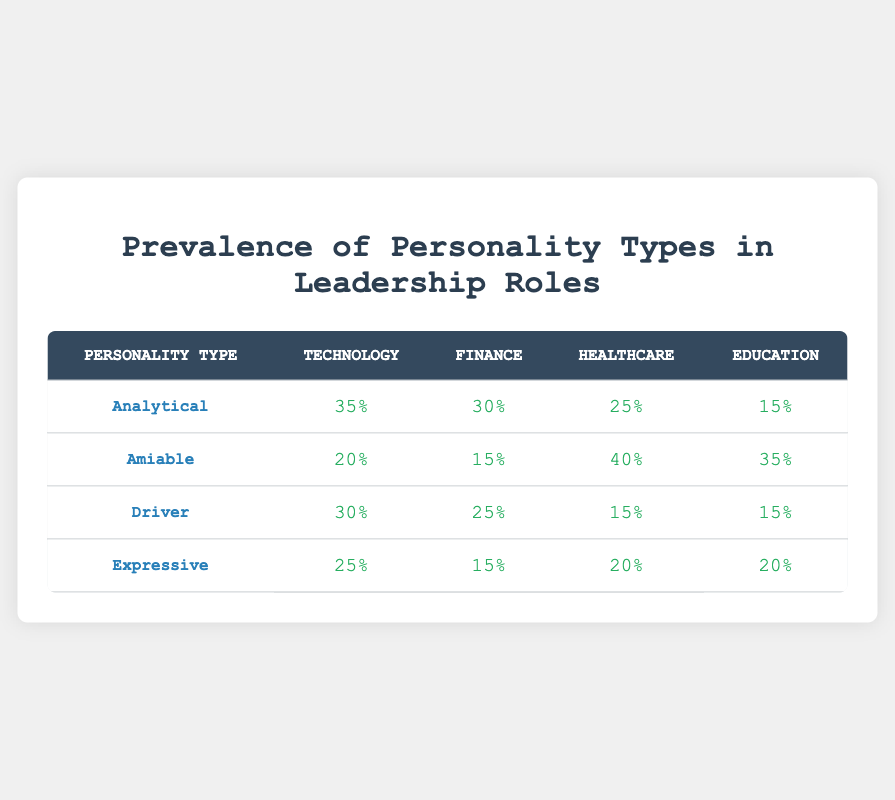What is the prevalence of Analytical personality types in the Technology sector? According to the table, the prevalence of Analytical personality types in the Technology sector is 35%.
Answer: 35% Which personality type has the highest prevalence in Healthcare? By looking at the Healthcare column, the Amiable personality type has the highest prevalence at 40%.
Answer: Amiable What is the average prevalence of the Expressive personality type across all industries? Adding the prevalence values of Expressive personality types: (25 + 15 + 20 + 20) = 80. Dividing this by the number of industries, which is 4, gives 80/4 = 20.
Answer: 20 Is it true that the Driver personality type has the lowest prevalence in Education? The table shows that the prevalence for the Driver personality type in Education is 15%, which is the same as its prevalence in Healthcare. However, the Amiable type has a higher prevalence of 35%, confirming that Driver is the lowest. Therefore, this statement is true.
Answer: Yes Which personality type is the most prevalent in the Finance sector? In the Finance sector, the highest values are for Analytical at 30% and Driver at 25%. Therefore, Analytical has the highest prevalence.
Answer: Analytical What is the difference in prevalence for the Amiable personality type between Healthcare and Technology? The Amiable prevalence in Healthcare is 40%, and in Technology, it is 20%. The difference is calculated as 40 - 20 = 20.
Answer: 20 Which industry shows a balanced prevalence of all personality types? By comparing the percentages across the industries, it appears that Education has a balanced approach to personality types compared to others, where no single type dominates significantly. The prevalence values are relatively close to each other, making it the most balanced.
Answer: Education What is the total prevalence of Analytical personality types across all industries? Adding the prevalence values of Analytical personality types: (35 + 30 + 25 + 15) = 105.
Answer: 105 Are there more industries where the prevalence of the Driver personality type is above 20% compared to those below? The only industries with Driver prevalence above 20% are Finance (25%) and Technology (30%). The other two, Healthcare and Education, have 15% each, giving us 2 industries above and 2 below. Therefore, the answer is no; they are equal.
Answer: No 